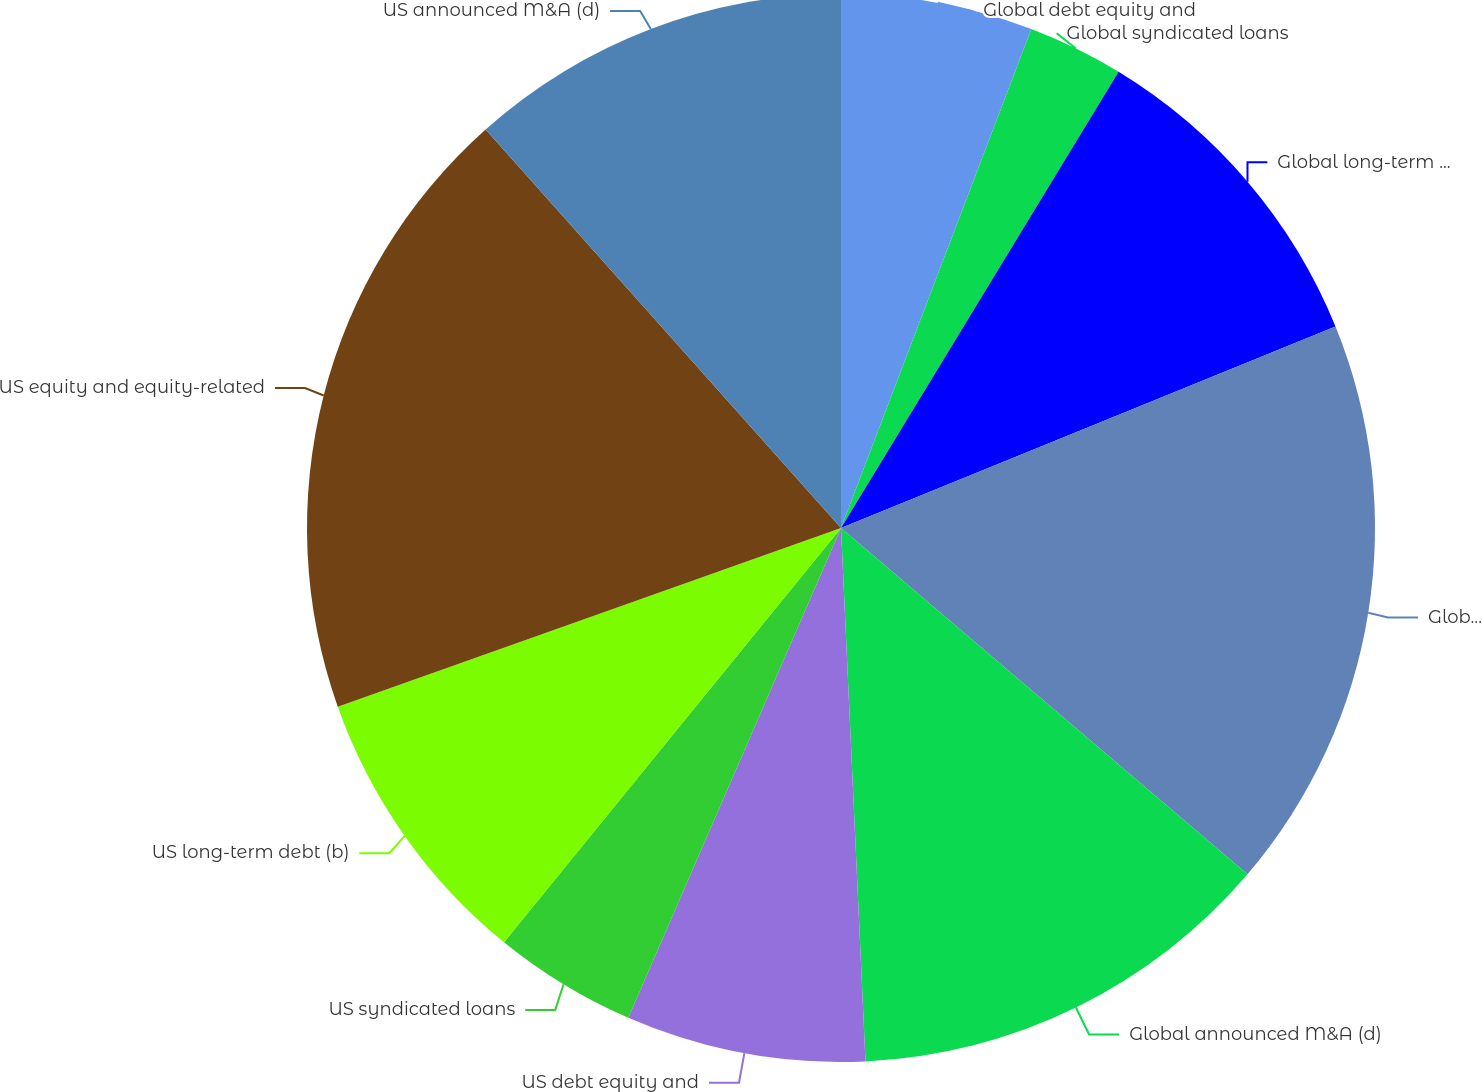Convert chart to OTSL. <chart><loc_0><loc_0><loc_500><loc_500><pie_chart><fcel>Global debt equity and<fcel>Global syndicated loans<fcel>Global long-term debt (b)<fcel>Global equity and<fcel>Global announced M&A (d)<fcel>US debt equity and<fcel>US syndicated loans<fcel>US long-term debt (b)<fcel>US equity and equity-related<fcel>US announced M&A (d)<nl><fcel>5.8%<fcel>2.9%<fcel>10.14%<fcel>17.39%<fcel>13.04%<fcel>7.25%<fcel>4.35%<fcel>8.7%<fcel>18.84%<fcel>11.59%<nl></chart> 